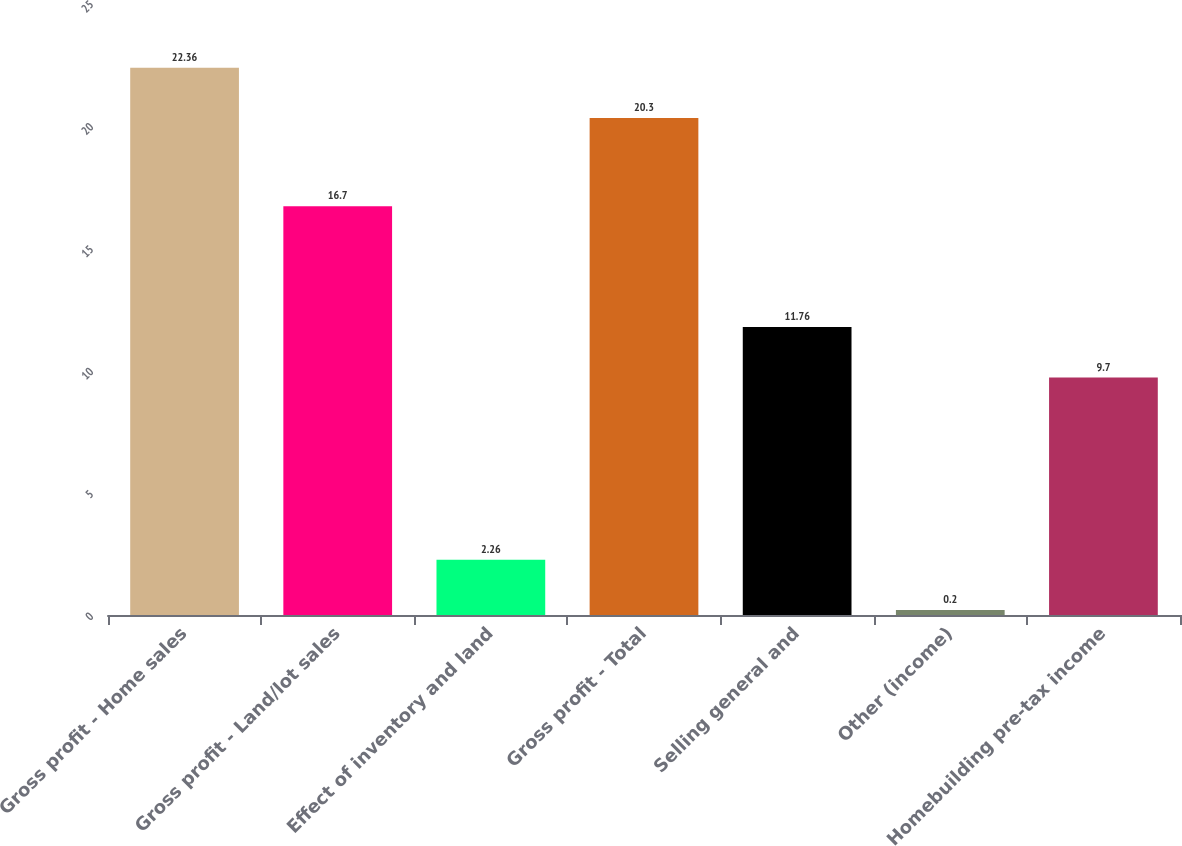<chart> <loc_0><loc_0><loc_500><loc_500><bar_chart><fcel>Gross profit - Home sales<fcel>Gross profit - Land/lot sales<fcel>Effect of inventory and land<fcel>Gross profit - Total<fcel>Selling general and<fcel>Other (income)<fcel>Homebuilding pre-tax income<nl><fcel>22.36<fcel>16.7<fcel>2.26<fcel>20.3<fcel>11.76<fcel>0.2<fcel>9.7<nl></chart> 